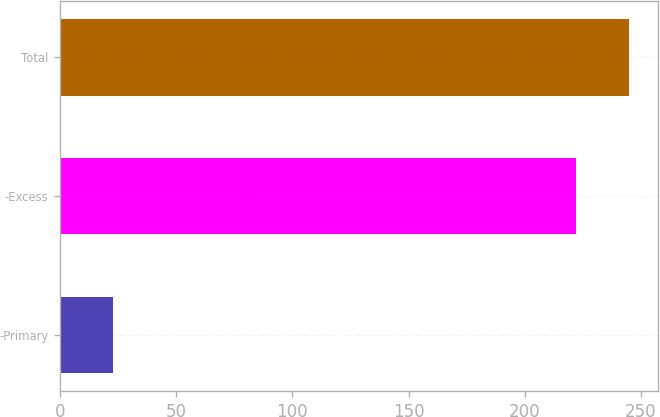Convert chart to OTSL. <chart><loc_0><loc_0><loc_500><loc_500><bar_chart><fcel>-Primary<fcel>-Excess<fcel>Total<nl><fcel>23<fcel>222<fcel>245<nl></chart> 